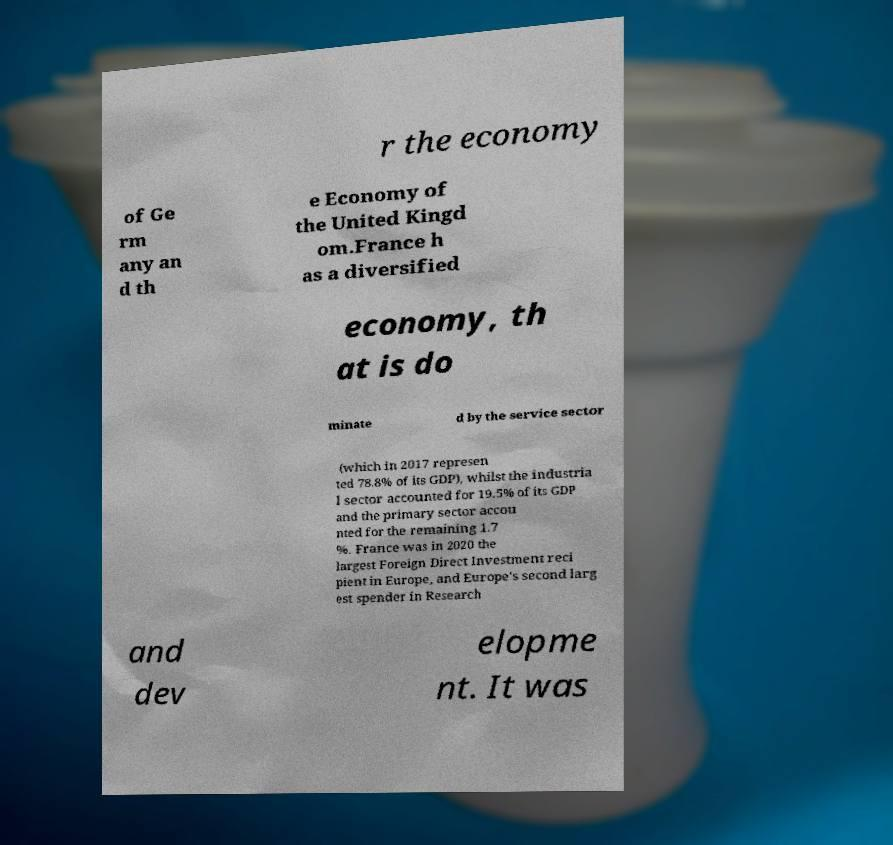Could you assist in decoding the text presented in this image and type it out clearly? r the economy of Ge rm any an d th e Economy of the United Kingd om.France h as a diversified economy, th at is do minate d by the service sector (which in 2017 represen ted 78.8% of its GDP), whilst the industria l sector accounted for 19.5% of its GDP and the primary sector accou nted for the remaining 1.7 %. France was in 2020 the largest Foreign Direct Investment reci pient in Europe, and Europe's second larg est spender in Research and dev elopme nt. It was 